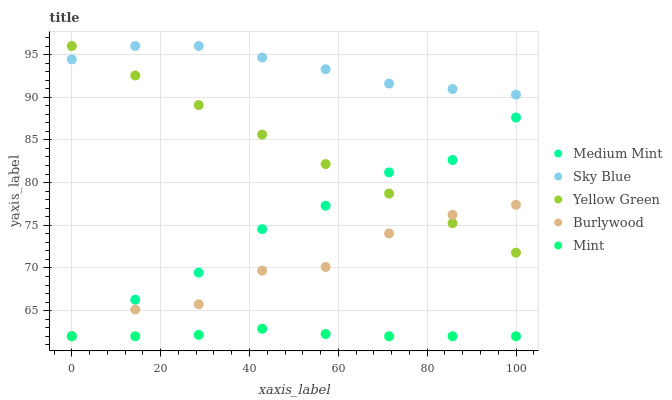Does Mint have the minimum area under the curve?
Answer yes or no. Yes. Does Sky Blue have the maximum area under the curve?
Answer yes or no. Yes. Does Sky Blue have the minimum area under the curve?
Answer yes or no. No. Does Mint have the maximum area under the curve?
Answer yes or no. No. Is Yellow Green the smoothest?
Answer yes or no. Yes. Is Burlywood the roughest?
Answer yes or no. Yes. Is Sky Blue the smoothest?
Answer yes or no. No. Is Sky Blue the roughest?
Answer yes or no. No. Does Medium Mint have the lowest value?
Answer yes or no. Yes. Does Sky Blue have the lowest value?
Answer yes or no. No. Does Yellow Green have the highest value?
Answer yes or no. Yes. Does Mint have the highest value?
Answer yes or no. No. Is Burlywood less than Sky Blue?
Answer yes or no. Yes. Is Sky Blue greater than Burlywood?
Answer yes or no. Yes. Does Sky Blue intersect Yellow Green?
Answer yes or no. Yes. Is Sky Blue less than Yellow Green?
Answer yes or no. No. Is Sky Blue greater than Yellow Green?
Answer yes or no. No. Does Burlywood intersect Sky Blue?
Answer yes or no. No. 